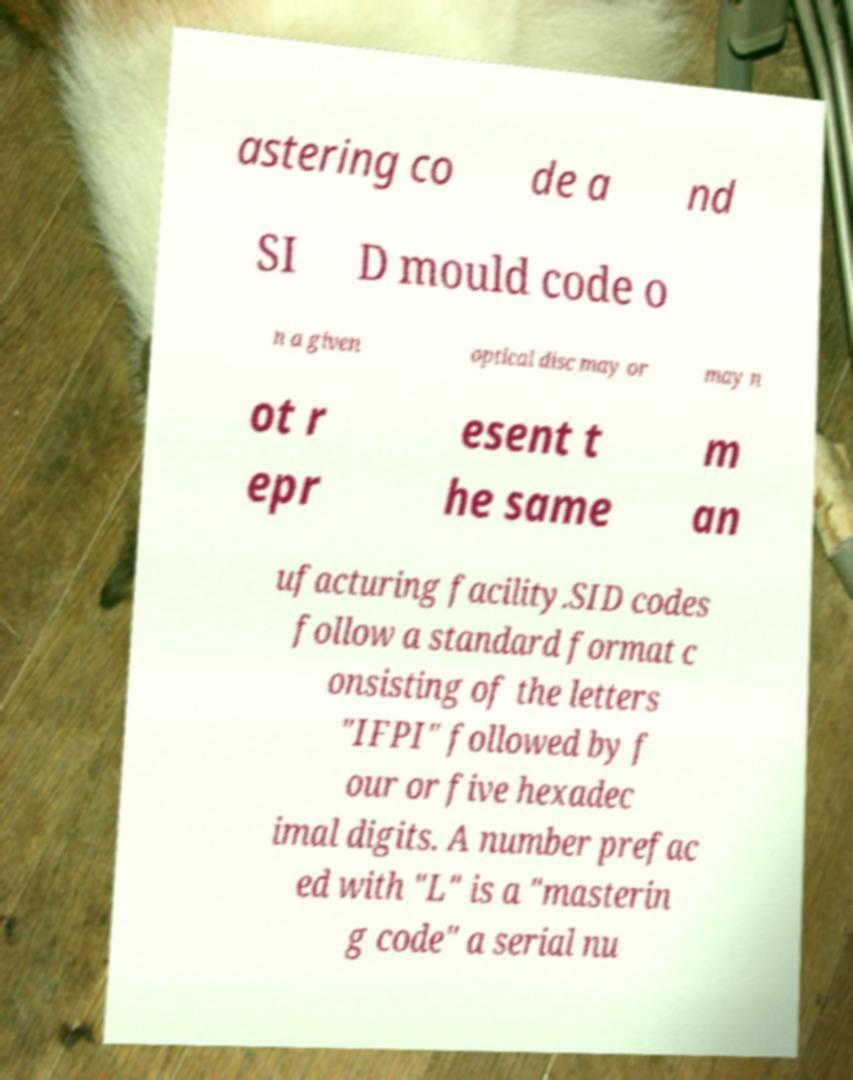For documentation purposes, I need the text within this image transcribed. Could you provide that? astering co de a nd SI D mould code o n a given optical disc may or may n ot r epr esent t he same m an ufacturing facility.SID codes follow a standard format c onsisting of the letters "IFPI" followed by f our or five hexadec imal digits. A number prefac ed with "L" is a "masterin g code" a serial nu 